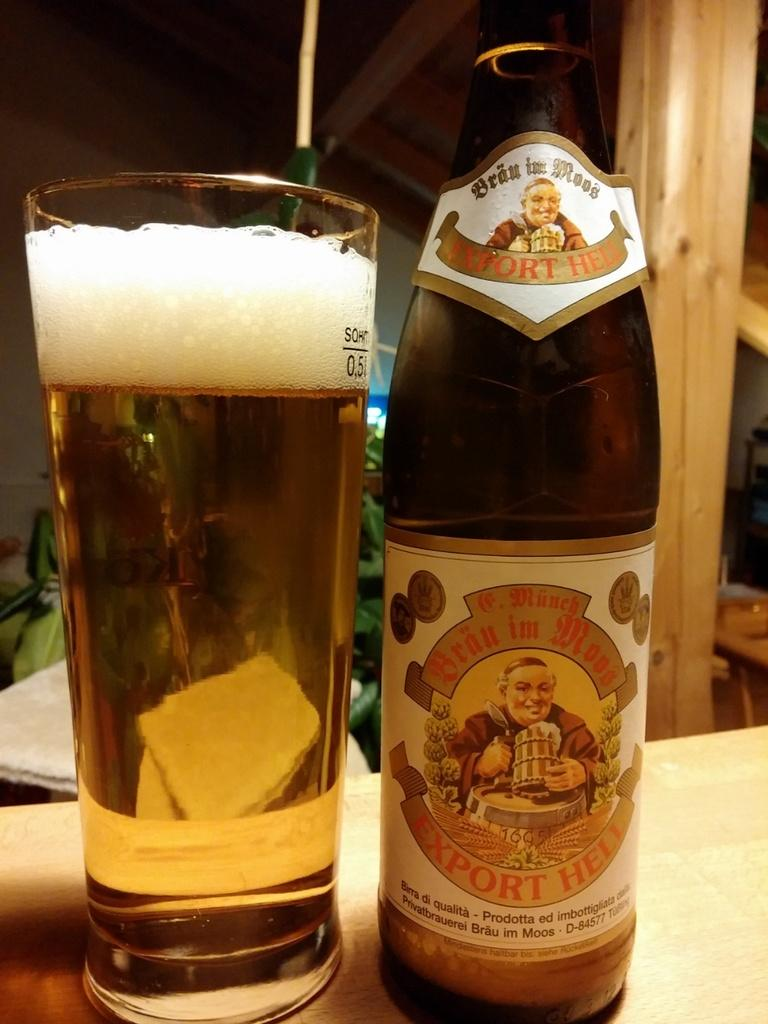<image>
Give a short and clear explanation of the subsequent image. A bottle of beer with a label that says Export Hell sits next to a glass of beer. 